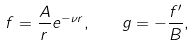<formula> <loc_0><loc_0><loc_500><loc_500>f = \frac { A } { r } e ^ { - \nu r } , \quad g = - \frac { f ^ { \prime } } { B } ,</formula> 